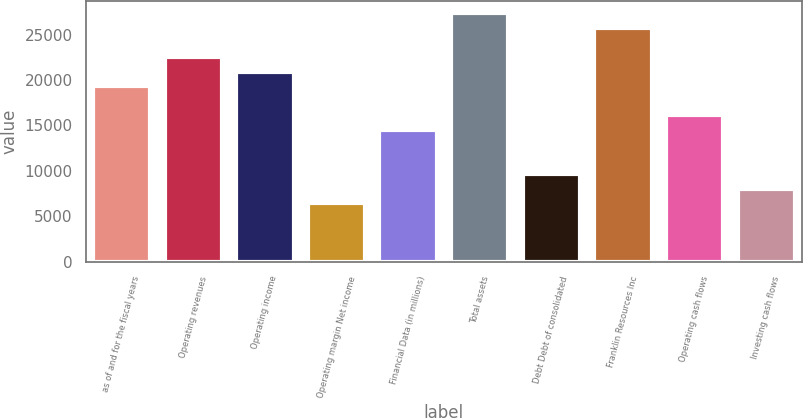Convert chart to OTSL. <chart><loc_0><loc_0><loc_500><loc_500><bar_chart><fcel>as of and for the fiscal years<fcel>Operating revenues<fcel>Operating income<fcel>Operating margin Net income<fcel>Financial Data (in millions)<fcel>Total assets<fcel>Debt Debt of consolidated<fcel>Franklin Resources Inc<fcel>Operating cash flows<fcel>Investing cash flows<nl><fcel>19318.4<fcel>22538.1<fcel>20928.2<fcel>6439.96<fcel>14489<fcel>27367.5<fcel>9659.58<fcel>25757.7<fcel>16098.8<fcel>8049.77<nl></chart> 